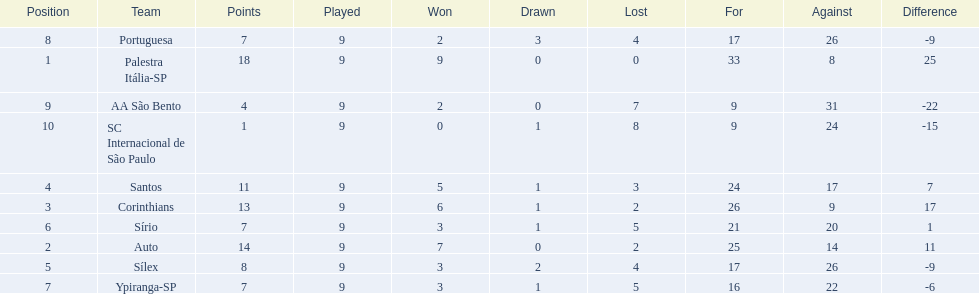How many points were scored by the teams? 18, 14, 13, 11, 8, 7, 7, 7, 4, 1. What team scored 13 points? Corinthians. Could you help me parse every detail presented in this table? {'header': ['Position', 'Team', 'Points', 'Played', 'Won', 'Drawn', 'Lost', 'For', 'Against', 'Difference'], 'rows': [['8', 'Portuguesa', '7', '9', '2', '3', '4', '17', '26', '-9'], ['1', 'Palestra Itália-SP', '18', '9', '9', '0', '0', '33', '8', '25'], ['9', 'AA São Bento', '4', '9', '2', '0', '7', '9', '31', '-22'], ['10', 'SC Internacional de São Paulo', '1', '9', '0', '1', '8', '9', '24', '-15'], ['4', 'Santos', '11', '9', '5', '1', '3', '24', '17', '7'], ['3', 'Corinthians', '13', '9', '6', '1', '2', '26', '9', '17'], ['6', 'Sírio', '7', '9', '3', '1', '5', '21', '20', '1'], ['2', 'Auto', '14', '9', '7', '0', '2', '25', '14', '11'], ['5', 'Sílex', '8', '9', '3', '2', '4', '17', '26', '-9'], ['7', 'Ypiranga-SP', '7', '9', '3', '1', '5', '16', '22', '-6']]} 